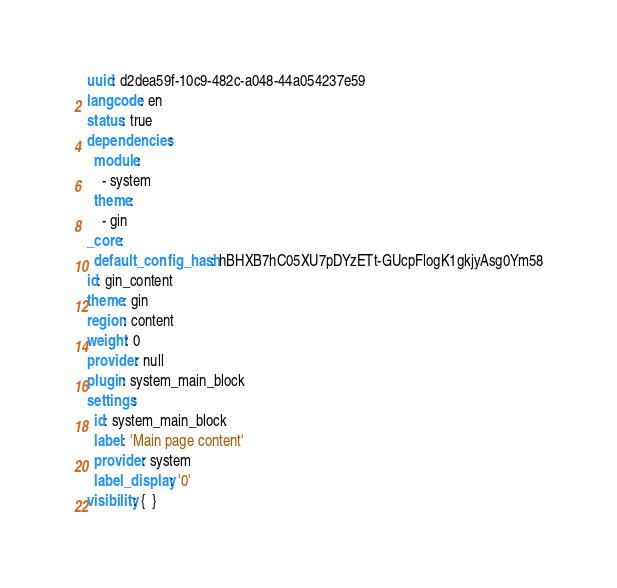<code> <loc_0><loc_0><loc_500><loc_500><_YAML_>uuid: d2dea59f-10c9-482c-a048-44a054237e59
langcode: en
status: true
dependencies:
  module:
    - system
  theme:
    - gin
_core:
  default_config_hash: hBHXB7hC05XU7pDYzETt-GUcpFlogK1gkjyAsg0Ym58
id: gin_content
theme: gin
region: content
weight: 0
provider: null
plugin: system_main_block
settings:
  id: system_main_block
  label: 'Main page content'
  provider: system
  label_display: '0'
visibility: {  }
</code> 